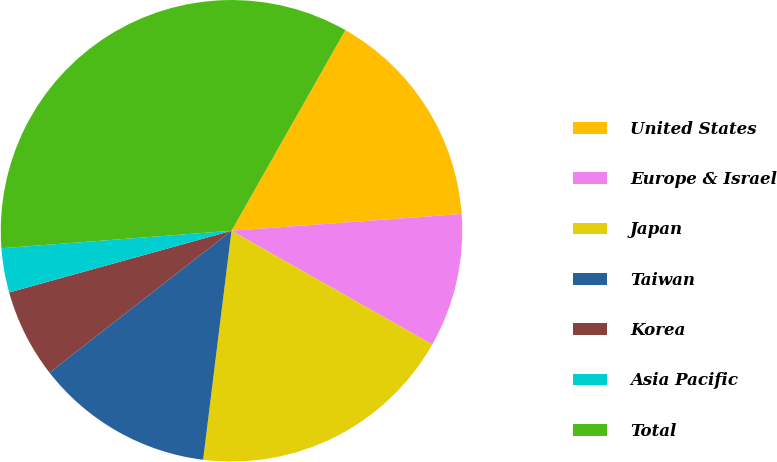Convert chart to OTSL. <chart><loc_0><loc_0><loc_500><loc_500><pie_chart><fcel>United States<fcel>Europe & Israel<fcel>Japan<fcel>Taiwan<fcel>Korea<fcel>Asia Pacific<fcel>Total<nl><fcel>15.63%<fcel>9.36%<fcel>18.76%<fcel>12.5%<fcel>6.23%<fcel>3.1%<fcel>34.42%<nl></chart> 